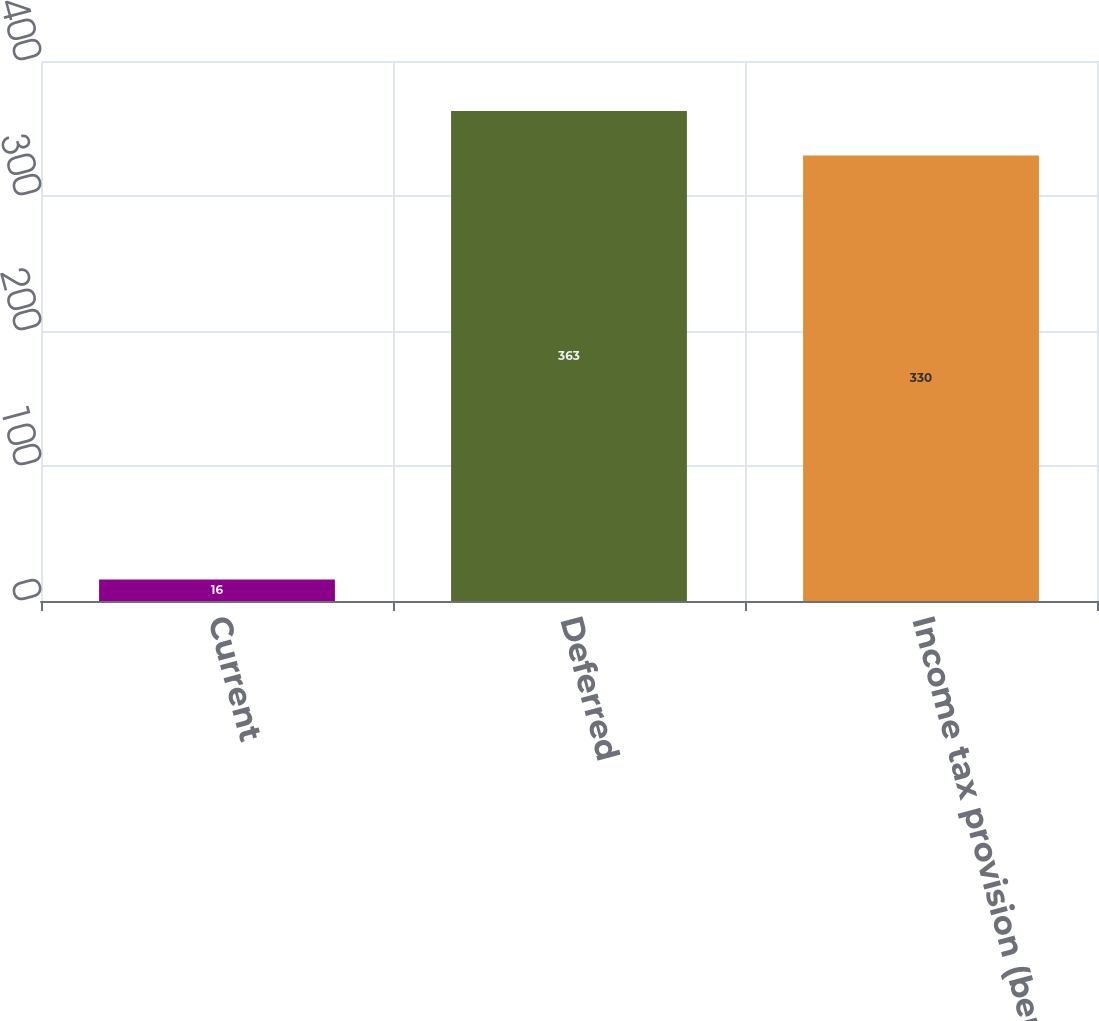Convert chart to OTSL. <chart><loc_0><loc_0><loc_500><loc_500><bar_chart><fcel>Current<fcel>Deferred<fcel>Income tax provision (benefit)<nl><fcel>16<fcel>363<fcel>330<nl></chart> 